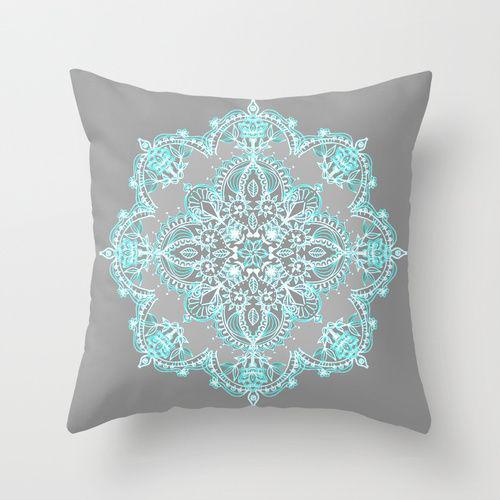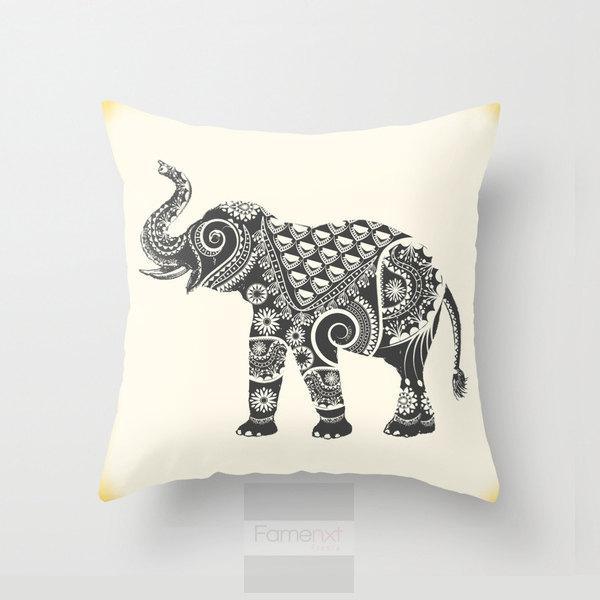The first image is the image on the left, the second image is the image on the right. For the images shown, is this caption "The pillows in the image on the left have words on them." true? Answer yes or no. No. The first image is the image on the left, the second image is the image on the right. Analyze the images presented: Is the assertion "The lefthand image shows a pillow decorated with at least one symmetrical sky-blue shape that resembles a snowflake." valid? Answer yes or no. Yes. 